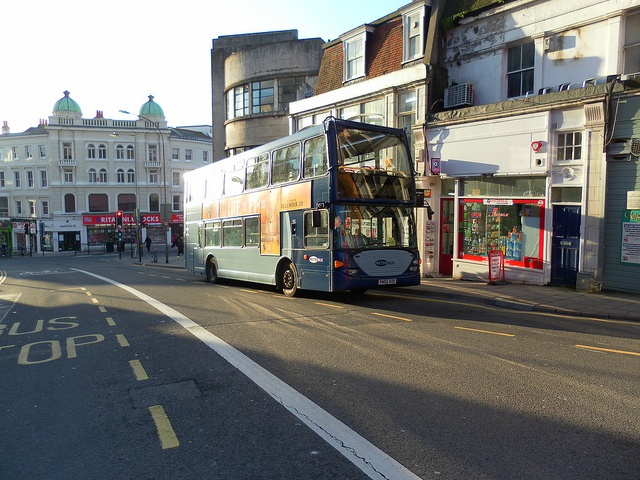Describe the objects in this image and their specific colors. I can see bus in white, black, gray, ivory, and darkgray tones, people in white, black, gray, and blue tones, people in white, black, gray, and purple tones, traffic light in white, black, gray, purple, and brown tones, and people in white, black, gray, darkblue, and purple tones in this image. 